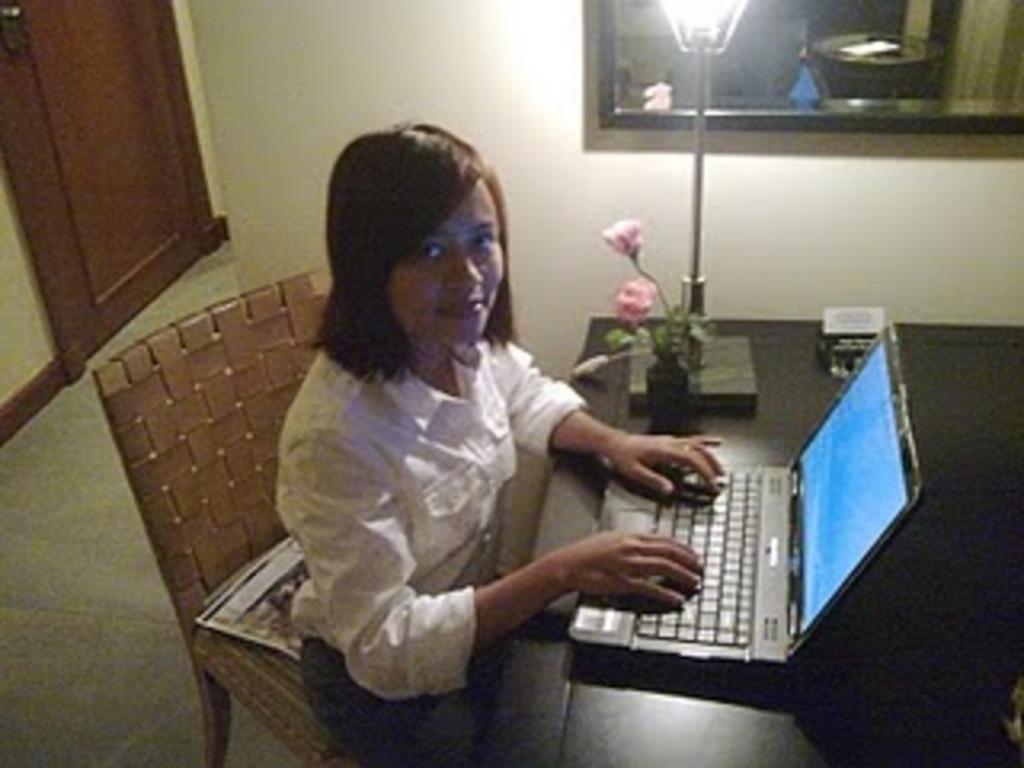Please provide a concise description of this image. In the image there is woman in white dress sitting in front of table with laptop in front of her along with a lamp and flower vase on it, on the right side there is a window on the wall, on the left side there is a door. 